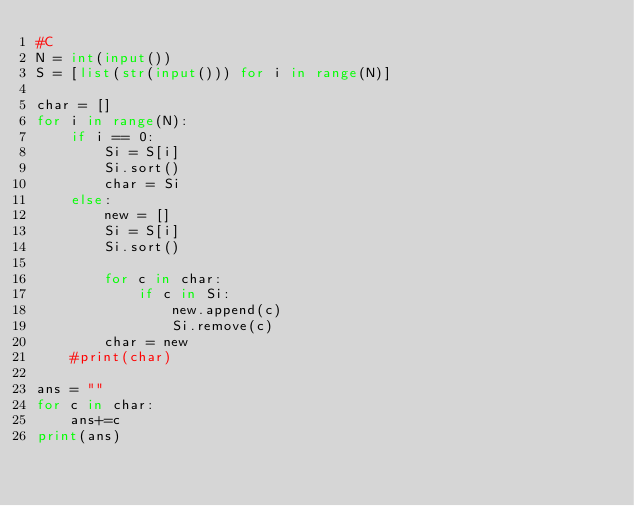Convert code to text. <code><loc_0><loc_0><loc_500><loc_500><_Python_>#C
N = int(input())
S = [list(str(input())) for i in range(N)]

char = []
for i in range(N):
    if i == 0:
        Si = S[i]
        Si.sort()
        char = Si
    else:
        new = []
        Si = S[i]
        Si.sort()
        
        for c in char:
            if c in Si:
                new.append(c)
                Si.remove(c)
        char = new
    #print(char)
        
ans = ""
for c in char:
    ans+=c
print(ans)
</code> 